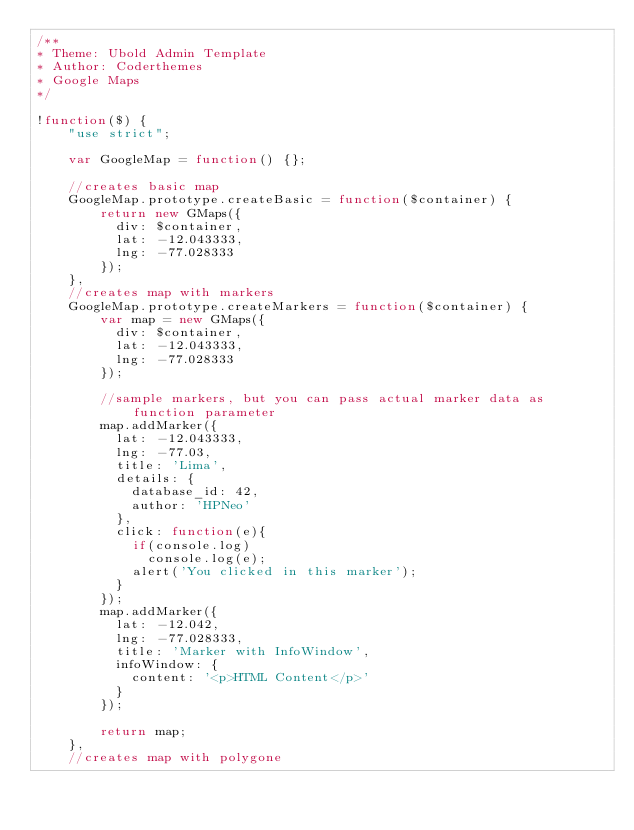<code> <loc_0><loc_0><loc_500><loc_500><_JavaScript_>/**
* Theme: Ubold Admin Template
* Author: Coderthemes
* Google Maps
*/

!function($) {
    "use strict";

    var GoogleMap = function() {};

    //creates basic map
    GoogleMap.prototype.createBasic = function($container) {
        return new GMaps({
          div: $container,
          lat: -12.043333,
          lng: -77.028333
        });
    },
    //creates map with markers
    GoogleMap.prototype.createMarkers = function($container) {
        var map = new GMaps({
          div: $container,
          lat: -12.043333,
          lng: -77.028333
        });

        //sample markers, but you can pass actual marker data as function parameter
        map.addMarker({
          lat: -12.043333,
          lng: -77.03,
          title: 'Lima',
          details: {
            database_id: 42,
            author: 'HPNeo'
          },
          click: function(e){
            if(console.log)
              console.log(e);
            alert('You clicked in this marker');
          }
        });
        map.addMarker({
          lat: -12.042,
          lng: -77.028333,
          title: 'Marker with InfoWindow',
          infoWindow: {
            content: '<p>HTML Content</p>'
          }
        });

        return map;
    },
    //creates map with polygone</code> 